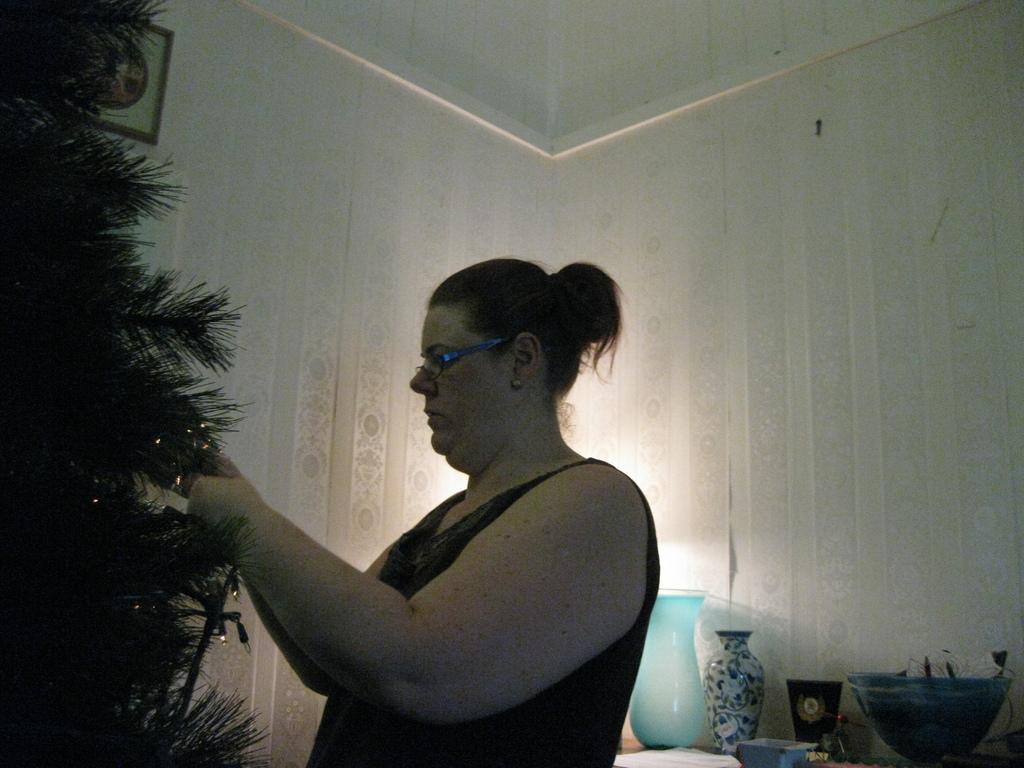Please provide a concise description of this image. In this image we can see a lady decorating a Christmas tree, there is a vase, a jar, bowl, and some other objects on the table, also we can see a photo frame on the wall.  